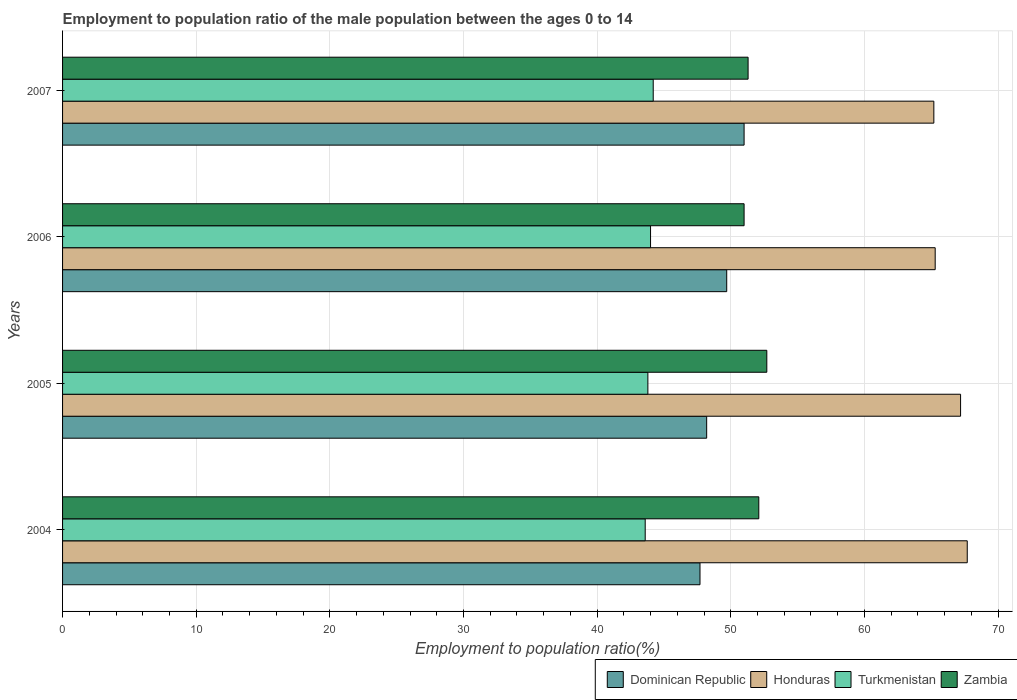Are the number of bars on each tick of the Y-axis equal?
Offer a terse response. Yes. What is the label of the 2nd group of bars from the top?
Ensure brevity in your answer.  2006. In how many cases, is the number of bars for a given year not equal to the number of legend labels?
Give a very brief answer. 0. What is the employment to population ratio in Turkmenistan in 2004?
Offer a terse response. 43.6. Across all years, what is the maximum employment to population ratio in Honduras?
Provide a succinct answer. 67.7. Across all years, what is the minimum employment to population ratio in Turkmenistan?
Your answer should be very brief. 43.6. In which year was the employment to population ratio in Dominican Republic minimum?
Give a very brief answer. 2004. What is the total employment to population ratio in Dominican Republic in the graph?
Offer a very short reply. 196.6. What is the difference between the employment to population ratio in Zambia in 2006 and that in 2007?
Offer a terse response. -0.3. What is the difference between the employment to population ratio in Dominican Republic in 2005 and the employment to population ratio in Zambia in 2007?
Provide a succinct answer. -3.1. What is the average employment to population ratio in Dominican Republic per year?
Give a very brief answer. 49.15. In the year 2004, what is the difference between the employment to population ratio in Dominican Republic and employment to population ratio in Honduras?
Offer a very short reply. -20. What is the ratio of the employment to population ratio in Dominican Republic in 2006 to that in 2007?
Give a very brief answer. 0.97. Is the difference between the employment to population ratio in Dominican Republic in 2006 and 2007 greater than the difference between the employment to population ratio in Honduras in 2006 and 2007?
Offer a very short reply. No. What is the difference between the highest and the second highest employment to population ratio in Dominican Republic?
Give a very brief answer. 1.3. What is the difference between the highest and the lowest employment to population ratio in Dominican Republic?
Provide a succinct answer. 3.3. What does the 1st bar from the top in 2006 represents?
Ensure brevity in your answer.  Zambia. What does the 1st bar from the bottom in 2004 represents?
Provide a succinct answer. Dominican Republic. How many years are there in the graph?
Offer a very short reply. 4. How many legend labels are there?
Provide a succinct answer. 4. What is the title of the graph?
Your answer should be compact. Employment to population ratio of the male population between the ages 0 to 14. Does "Burundi" appear as one of the legend labels in the graph?
Your response must be concise. No. What is the label or title of the X-axis?
Offer a terse response. Employment to population ratio(%). What is the label or title of the Y-axis?
Your answer should be compact. Years. What is the Employment to population ratio(%) of Dominican Republic in 2004?
Your response must be concise. 47.7. What is the Employment to population ratio(%) of Honduras in 2004?
Your response must be concise. 67.7. What is the Employment to population ratio(%) of Turkmenistan in 2004?
Keep it short and to the point. 43.6. What is the Employment to population ratio(%) of Zambia in 2004?
Provide a short and direct response. 52.1. What is the Employment to population ratio(%) of Dominican Republic in 2005?
Offer a very short reply. 48.2. What is the Employment to population ratio(%) of Honduras in 2005?
Make the answer very short. 67.2. What is the Employment to population ratio(%) in Turkmenistan in 2005?
Your response must be concise. 43.8. What is the Employment to population ratio(%) in Zambia in 2005?
Keep it short and to the point. 52.7. What is the Employment to population ratio(%) of Dominican Republic in 2006?
Offer a terse response. 49.7. What is the Employment to population ratio(%) in Honduras in 2006?
Your answer should be very brief. 65.3. What is the Employment to population ratio(%) of Honduras in 2007?
Make the answer very short. 65.2. What is the Employment to population ratio(%) of Turkmenistan in 2007?
Your answer should be very brief. 44.2. What is the Employment to population ratio(%) of Zambia in 2007?
Your response must be concise. 51.3. Across all years, what is the maximum Employment to population ratio(%) in Dominican Republic?
Make the answer very short. 51. Across all years, what is the maximum Employment to population ratio(%) in Honduras?
Make the answer very short. 67.7. Across all years, what is the maximum Employment to population ratio(%) of Turkmenistan?
Your response must be concise. 44.2. Across all years, what is the maximum Employment to population ratio(%) of Zambia?
Make the answer very short. 52.7. Across all years, what is the minimum Employment to population ratio(%) of Dominican Republic?
Offer a terse response. 47.7. Across all years, what is the minimum Employment to population ratio(%) in Honduras?
Ensure brevity in your answer.  65.2. Across all years, what is the minimum Employment to population ratio(%) of Turkmenistan?
Make the answer very short. 43.6. Across all years, what is the minimum Employment to population ratio(%) in Zambia?
Offer a very short reply. 51. What is the total Employment to population ratio(%) in Dominican Republic in the graph?
Give a very brief answer. 196.6. What is the total Employment to population ratio(%) in Honduras in the graph?
Offer a very short reply. 265.4. What is the total Employment to population ratio(%) in Turkmenistan in the graph?
Your answer should be compact. 175.6. What is the total Employment to population ratio(%) of Zambia in the graph?
Keep it short and to the point. 207.1. What is the difference between the Employment to population ratio(%) in Turkmenistan in 2004 and that in 2005?
Your answer should be very brief. -0.2. What is the difference between the Employment to population ratio(%) in Dominican Republic in 2004 and that in 2006?
Provide a succinct answer. -2. What is the difference between the Employment to population ratio(%) in Honduras in 2004 and that in 2006?
Your answer should be compact. 2.4. What is the difference between the Employment to population ratio(%) in Turkmenistan in 2004 and that in 2007?
Provide a succinct answer. -0.6. What is the difference between the Employment to population ratio(%) of Zambia in 2004 and that in 2007?
Give a very brief answer. 0.8. What is the difference between the Employment to population ratio(%) of Dominican Republic in 2005 and that in 2006?
Offer a very short reply. -1.5. What is the difference between the Employment to population ratio(%) in Honduras in 2005 and that in 2006?
Your answer should be very brief. 1.9. What is the difference between the Employment to population ratio(%) in Turkmenistan in 2005 and that in 2006?
Provide a short and direct response. -0.2. What is the difference between the Employment to population ratio(%) of Zambia in 2005 and that in 2006?
Provide a short and direct response. 1.7. What is the difference between the Employment to population ratio(%) in Dominican Republic in 2005 and that in 2007?
Your answer should be compact. -2.8. What is the difference between the Employment to population ratio(%) of Turkmenistan in 2005 and that in 2007?
Ensure brevity in your answer.  -0.4. What is the difference between the Employment to population ratio(%) in Zambia in 2005 and that in 2007?
Keep it short and to the point. 1.4. What is the difference between the Employment to population ratio(%) in Turkmenistan in 2006 and that in 2007?
Ensure brevity in your answer.  -0.2. What is the difference between the Employment to population ratio(%) of Dominican Republic in 2004 and the Employment to population ratio(%) of Honduras in 2005?
Your response must be concise. -19.5. What is the difference between the Employment to population ratio(%) in Dominican Republic in 2004 and the Employment to population ratio(%) in Zambia in 2005?
Provide a short and direct response. -5. What is the difference between the Employment to population ratio(%) in Honduras in 2004 and the Employment to population ratio(%) in Turkmenistan in 2005?
Offer a terse response. 23.9. What is the difference between the Employment to population ratio(%) of Honduras in 2004 and the Employment to population ratio(%) of Zambia in 2005?
Offer a terse response. 15. What is the difference between the Employment to population ratio(%) in Dominican Republic in 2004 and the Employment to population ratio(%) in Honduras in 2006?
Provide a short and direct response. -17.6. What is the difference between the Employment to population ratio(%) of Dominican Republic in 2004 and the Employment to population ratio(%) of Turkmenistan in 2006?
Offer a very short reply. 3.7. What is the difference between the Employment to population ratio(%) in Honduras in 2004 and the Employment to population ratio(%) in Turkmenistan in 2006?
Your answer should be compact. 23.7. What is the difference between the Employment to population ratio(%) of Dominican Republic in 2004 and the Employment to population ratio(%) of Honduras in 2007?
Your answer should be compact. -17.5. What is the difference between the Employment to population ratio(%) in Dominican Republic in 2004 and the Employment to population ratio(%) in Turkmenistan in 2007?
Offer a terse response. 3.5. What is the difference between the Employment to population ratio(%) of Dominican Republic in 2004 and the Employment to population ratio(%) of Zambia in 2007?
Offer a very short reply. -3.6. What is the difference between the Employment to population ratio(%) in Honduras in 2004 and the Employment to population ratio(%) in Turkmenistan in 2007?
Offer a very short reply. 23.5. What is the difference between the Employment to population ratio(%) in Turkmenistan in 2004 and the Employment to population ratio(%) in Zambia in 2007?
Make the answer very short. -7.7. What is the difference between the Employment to population ratio(%) in Dominican Republic in 2005 and the Employment to population ratio(%) in Honduras in 2006?
Provide a short and direct response. -17.1. What is the difference between the Employment to population ratio(%) of Dominican Republic in 2005 and the Employment to population ratio(%) of Turkmenistan in 2006?
Ensure brevity in your answer.  4.2. What is the difference between the Employment to population ratio(%) of Honduras in 2005 and the Employment to population ratio(%) of Turkmenistan in 2006?
Make the answer very short. 23.2. What is the difference between the Employment to population ratio(%) of Honduras in 2005 and the Employment to population ratio(%) of Zambia in 2006?
Offer a terse response. 16.2. What is the difference between the Employment to population ratio(%) of Dominican Republic in 2005 and the Employment to population ratio(%) of Zambia in 2007?
Make the answer very short. -3.1. What is the difference between the Employment to population ratio(%) in Honduras in 2005 and the Employment to population ratio(%) in Turkmenistan in 2007?
Give a very brief answer. 23. What is the difference between the Employment to population ratio(%) of Honduras in 2005 and the Employment to population ratio(%) of Zambia in 2007?
Provide a succinct answer. 15.9. What is the difference between the Employment to population ratio(%) in Dominican Republic in 2006 and the Employment to population ratio(%) in Honduras in 2007?
Give a very brief answer. -15.5. What is the difference between the Employment to population ratio(%) of Honduras in 2006 and the Employment to population ratio(%) of Turkmenistan in 2007?
Your answer should be very brief. 21.1. What is the difference between the Employment to population ratio(%) in Honduras in 2006 and the Employment to population ratio(%) in Zambia in 2007?
Provide a short and direct response. 14. What is the average Employment to population ratio(%) in Dominican Republic per year?
Offer a terse response. 49.15. What is the average Employment to population ratio(%) of Honduras per year?
Your response must be concise. 66.35. What is the average Employment to population ratio(%) in Turkmenistan per year?
Provide a short and direct response. 43.9. What is the average Employment to population ratio(%) of Zambia per year?
Your response must be concise. 51.77. In the year 2004, what is the difference between the Employment to population ratio(%) in Dominican Republic and Employment to population ratio(%) in Zambia?
Provide a short and direct response. -4.4. In the year 2004, what is the difference between the Employment to population ratio(%) in Honduras and Employment to population ratio(%) in Turkmenistan?
Keep it short and to the point. 24.1. In the year 2004, what is the difference between the Employment to population ratio(%) of Turkmenistan and Employment to population ratio(%) of Zambia?
Offer a terse response. -8.5. In the year 2005, what is the difference between the Employment to population ratio(%) of Dominican Republic and Employment to population ratio(%) of Turkmenistan?
Offer a very short reply. 4.4. In the year 2005, what is the difference between the Employment to population ratio(%) in Dominican Republic and Employment to population ratio(%) in Zambia?
Ensure brevity in your answer.  -4.5. In the year 2005, what is the difference between the Employment to population ratio(%) in Honduras and Employment to population ratio(%) in Turkmenistan?
Your answer should be compact. 23.4. In the year 2005, what is the difference between the Employment to population ratio(%) in Honduras and Employment to population ratio(%) in Zambia?
Offer a terse response. 14.5. In the year 2006, what is the difference between the Employment to population ratio(%) of Dominican Republic and Employment to population ratio(%) of Honduras?
Make the answer very short. -15.6. In the year 2006, what is the difference between the Employment to population ratio(%) in Dominican Republic and Employment to population ratio(%) in Zambia?
Ensure brevity in your answer.  -1.3. In the year 2006, what is the difference between the Employment to population ratio(%) of Honduras and Employment to population ratio(%) of Turkmenistan?
Offer a terse response. 21.3. In the year 2007, what is the difference between the Employment to population ratio(%) of Dominican Republic and Employment to population ratio(%) of Honduras?
Your response must be concise. -14.2. What is the ratio of the Employment to population ratio(%) of Honduras in 2004 to that in 2005?
Your answer should be compact. 1.01. What is the ratio of the Employment to population ratio(%) of Zambia in 2004 to that in 2005?
Give a very brief answer. 0.99. What is the ratio of the Employment to population ratio(%) in Dominican Republic in 2004 to that in 2006?
Your response must be concise. 0.96. What is the ratio of the Employment to population ratio(%) in Honduras in 2004 to that in 2006?
Provide a succinct answer. 1.04. What is the ratio of the Employment to population ratio(%) in Turkmenistan in 2004 to that in 2006?
Keep it short and to the point. 0.99. What is the ratio of the Employment to population ratio(%) in Zambia in 2004 to that in 2006?
Offer a very short reply. 1.02. What is the ratio of the Employment to population ratio(%) in Dominican Republic in 2004 to that in 2007?
Give a very brief answer. 0.94. What is the ratio of the Employment to population ratio(%) in Honduras in 2004 to that in 2007?
Ensure brevity in your answer.  1.04. What is the ratio of the Employment to population ratio(%) of Turkmenistan in 2004 to that in 2007?
Offer a very short reply. 0.99. What is the ratio of the Employment to population ratio(%) of Zambia in 2004 to that in 2007?
Your response must be concise. 1.02. What is the ratio of the Employment to population ratio(%) of Dominican Republic in 2005 to that in 2006?
Offer a terse response. 0.97. What is the ratio of the Employment to population ratio(%) in Honduras in 2005 to that in 2006?
Provide a short and direct response. 1.03. What is the ratio of the Employment to population ratio(%) in Turkmenistan in 2005 to that in 2006?
Offer a very short reply. 1. What is the ratio of the Employment to population ratio(%) in Dominican Republic in 2005 to that in 2007?
Your answer should be compact. 0.95. What is the ratio of the Employment to population ratio(%) in Honduras in 2005 to that in 2007?
Give a very brief answer. 1.03. What is the ratio of the Employment to population ratio(%) of Zambia in 2005 to that in 2007?
Your answer should be compact. 1.03. What is the ratio of the Employment to population ratio(%) of Dominican Republic in 2006 to that in 2007?
Your answer should be very brief. 0.97. What is the ratio of the Employment to population ratio(%) of Honduras in 2006 to that in 2007?
Ensure brevity in your answer.  1. What is the ratio of the Employment to population ratio(%) of Turkmenistan in 2006 to that in 2007?
Your answer should be compact. 1. What is the difference between the highest and the second highest Employment to population ratio(%) of Honduras?
Provide a succinct answer. 0.5. What is the difference between the highest and the lowest Employment to population ratio(%) in Dominican Republic?
Keep it short and to the point. 3.3. What is the difference between the highest and the lowest Employment to population ratio(%) in Turkmenistan?
Keep it short and to the point. 0.6. 